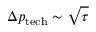Convert formula to latex. <formula><loc_0><loc_0><loc_500><loc_500>\Delta p _ { t e c h } \sim \sqrt { \tau }</formula> 